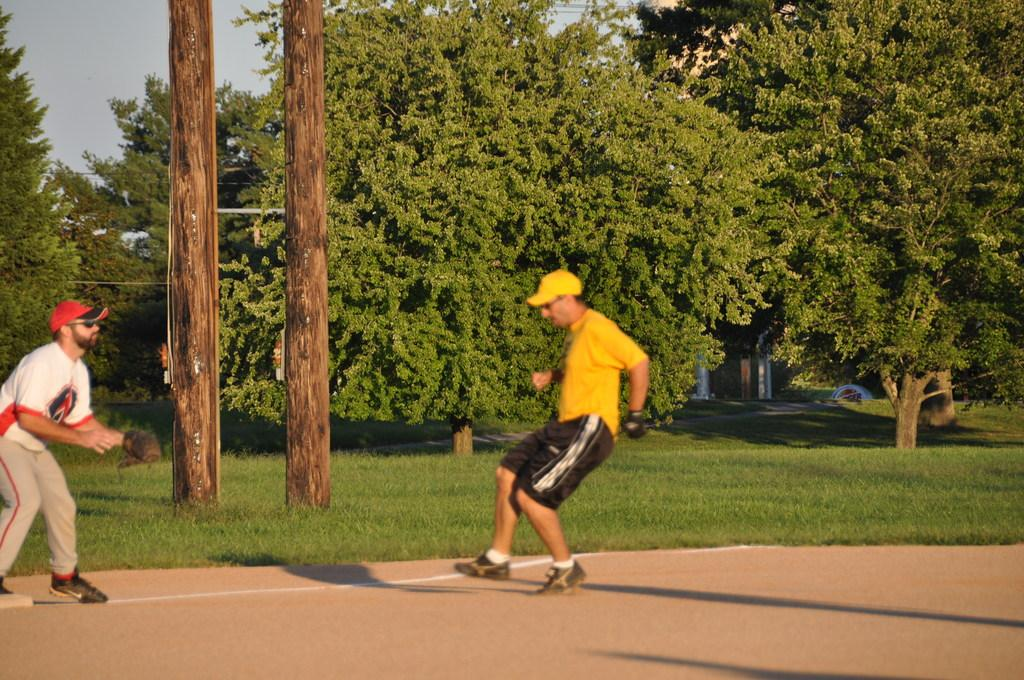How many people are in the foreground of the image? There are two persons in the foreground of the image. Where are the two persons located? The two persons are on the road. What can be seen in the background of the image? In the background of the image, there is grass, poles, trees, houses, and the sky. Can you describe the time of day when the image was likely taken? The image was likely taken during the day, as the sky is visible and there is no indication of darkness. What type of bun is being used as a prop in the image? There is no bun present in the image; it features two persons on the road and various background elements. 